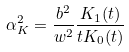<formula> <loc_0><loc_0><loc_500><loc_500>\alpha _ { K } ^ { 2 } = \frac { b ^ { 2 } } { w ^ { 2 } } \frac { K _ { 1 } ( t ) } { t K _ { 0 } ( t ) }</formula> 